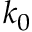<formula> <loc_0><loc_0><loc_500><loc_500>k _ { 0 }</formula> 